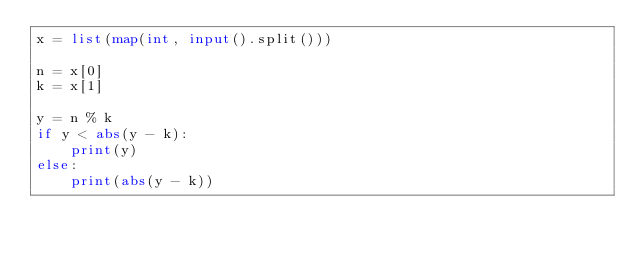<code> <loc_0><loc_0><loc_500><loc_500><_Python_>x = list(map(int, input().split()))

n = x[0]
k = x[1]

y = n % k
if y < abs(y - k):
    print(y)
else:
    print(abs(y - k))</code> 